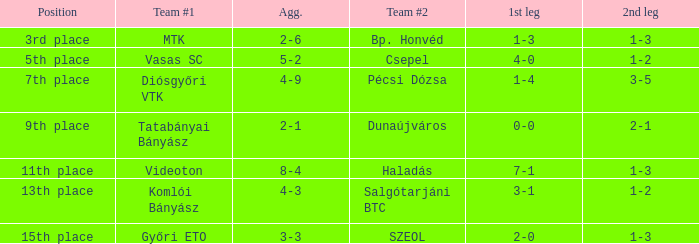What is the second part of the 4-9 aggregate? 3-5. 